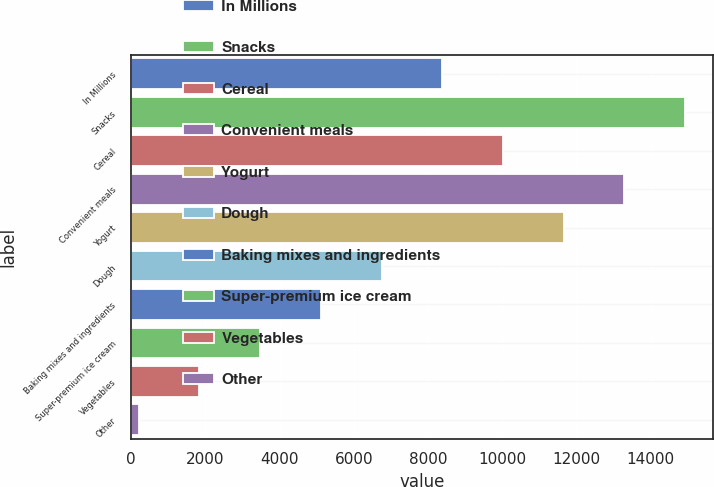Convert chart. <chart><loc_0><loc_0><loc_500><loc_500><bar_chart><fcel>In Millions<fcel>Snacks<fcel>Cereal<fcel>Convenient meals<fcel>Yogurt<fcel>Dough<fcel>Baking mixes and ingredients<fcel>Super-premium ice cream<fcel>Vegetables<fcel>Other<nl><fcel>8384.9<fcel>14927.5<fcel>10020.5<fcel>13291.8<fcel>11656.2<fcel>6749.26<fcel>5113.62<fcel>3477.98<fcel>1842.34<fcel>206.7<nl></chart> 